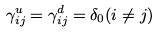Convert formula to latex. <formula><loc_0><loc_0><loc_500><loc_500>\gamma ^ { u } _ { i j } = \gamma ^ { d } _ { i j } = \delta _ { 0 } ( i \neq j )</formula> 